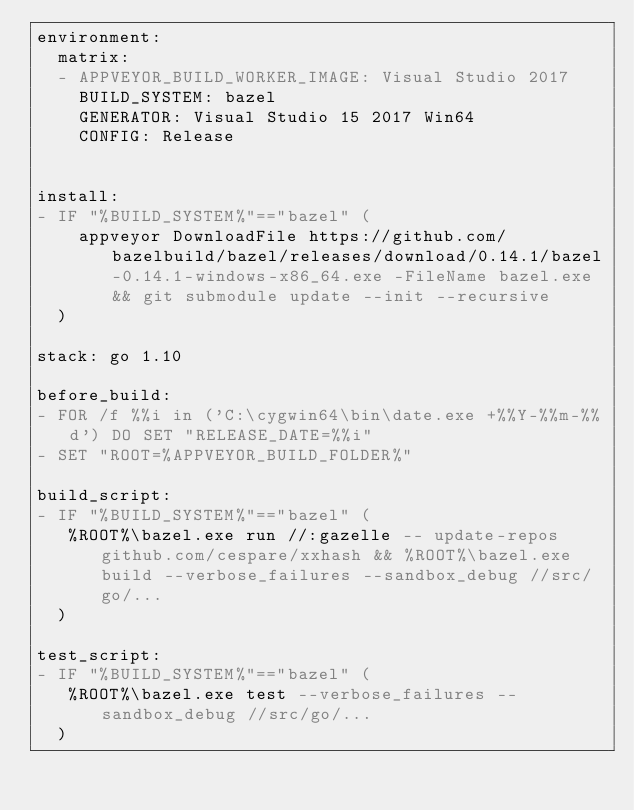<code> <loc_0><loc_0><loc_500><loc_500><_YAML_>environment:
  matrix:
  - APPVEYOR_BUILD_WORKER_IMAGE: Visual Studio 2017
    BUILD_SYSTEM: bazel
    GENERATOR: Visual Studio 15 2017 Win64
    CONFIG: Release


install:
- IF "%BUILD_SYSTEM%"=="bazel" (
    appveyor DownloadFile https://github.com/bazelbuild/bazel/releases/download/0.14.1/bazel-0.14.1-windows-x86_64.exe -FileName bazel.exe && git submodule update --init --recursive
  )

stack: go 1.10

before_build:
- FOR /f %%i in ('C:\cygwin64\bin\date.exe +%%Y-%%m-%%d') DO SET "RELEASE_DATE=%%i"
- SET "ROOT=%APPVEYOR_BUILD_FOLDER%"

build_script:
- IF "%BUILD_SYSTEM%"=="bazel" (
   %ROOT%\bazel.exe run //:gazelle -- update-repos github.com/cespare/xxhash && %ROOT%\bazel.exe build --verbose_failures --sandbox_debug //src/go/...
  )

test_script:
- IF "%BUILD_SYSTEM%"=="bazel" (
   %ROOT%\bazel.exe test --verbose_failures --sandbox_debug //src/go/...
  )
</code> 